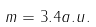Convert formula to latex. <formula><loc_0><loc_0><loc_500><loc_500>m = 3 . 4 a . u .</formula> 